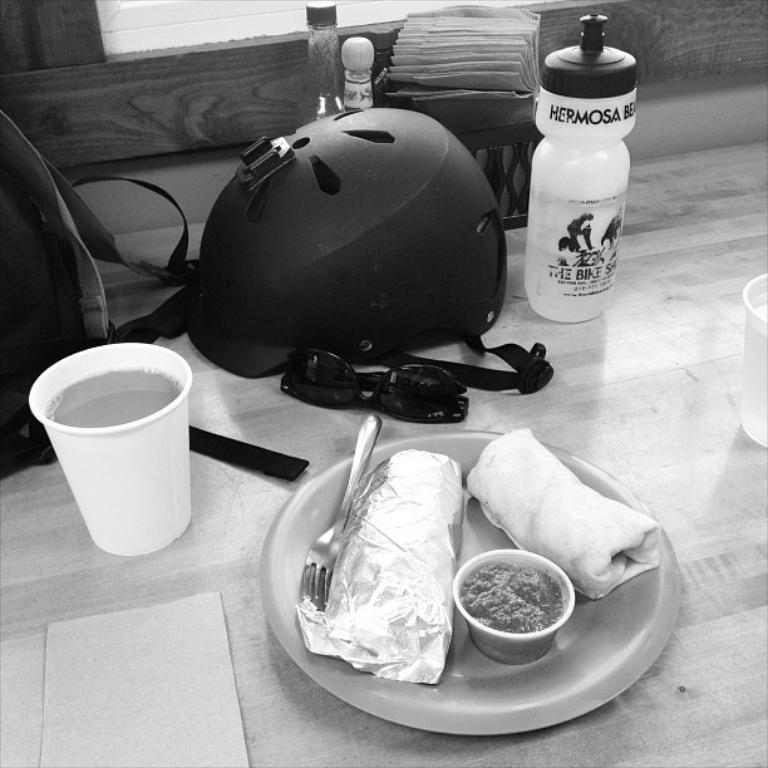What type of dishware can be seen in the image? There is a plate in the image. What type of beverage container is present? There is a glass in the image. What type of protective gear is visible? There is a helmet in the image. What type of containers are present for holding liquids? There are bottles in the image. What type of carrying device is present? There is a bag in the image. What type of eyewear is present? There are spectacles in the image. What type of seed can be seen growing on the table in the image? There is no seed present in the image; the objects mentioned are a plate, a glass, a helmet, bottles, a bag, and spectacles, all of which are on a table. 